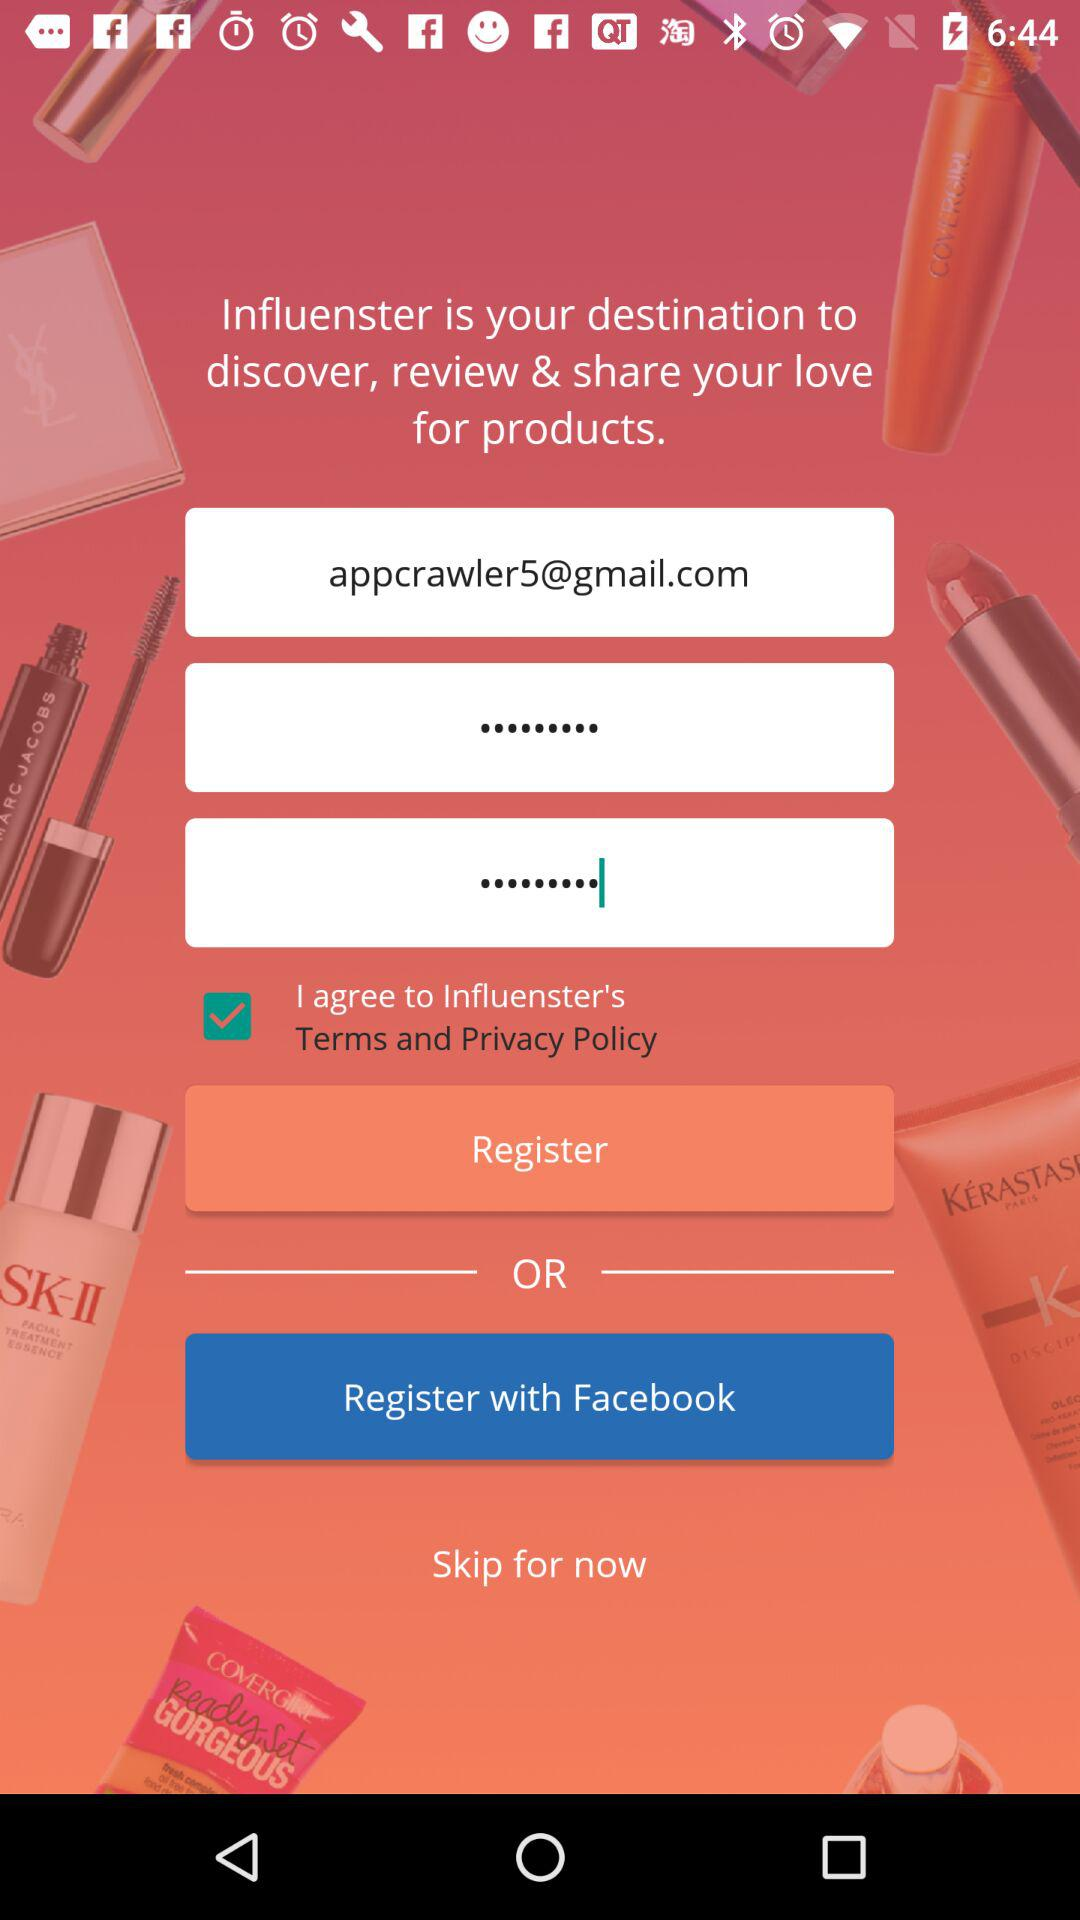What is the email address? The email address is appcrawler5@gmail.com. 